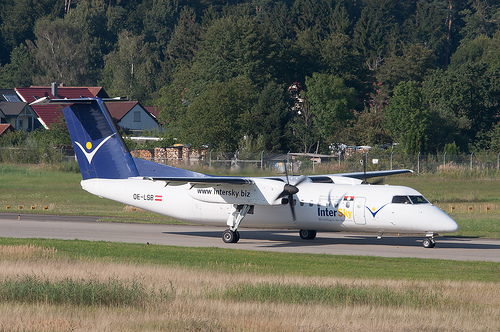How do the different shades of green in the image influence the overall aesthetic? The different shades of green within the image contribute significantly to its overall aesthetic. The lighter greens of the freshly mowed grass next to the runway contrast with the deeper greens of the surrounding trees, creating a layered effect that adds depth to the scene. This variation in greens draws the eye naturally across the image, providing a rich context that balances the stark whites and blues of the airplane, resulting in a harmonious and visually pleasing composition. 